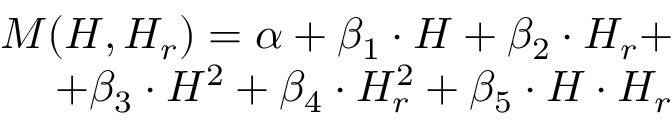Convert formula to latex. <formula><loc_0><loc_0><loc_500><loc_500>\begin{array} { r } { M ( H , H _ { r } ) = \alpha + \beta _ { 1 } \cdot H + \beta _ { 2 } \cdot H _ { r } + } \\ { + \beta _ { 3 } \cdot H ^ { 2 } + \beta _ { 4 } \cdot H _ { r } ^ { 2 } + \beta _ { 5 } \cdot H \cdot H _ { r } } \end{array}</formula> 